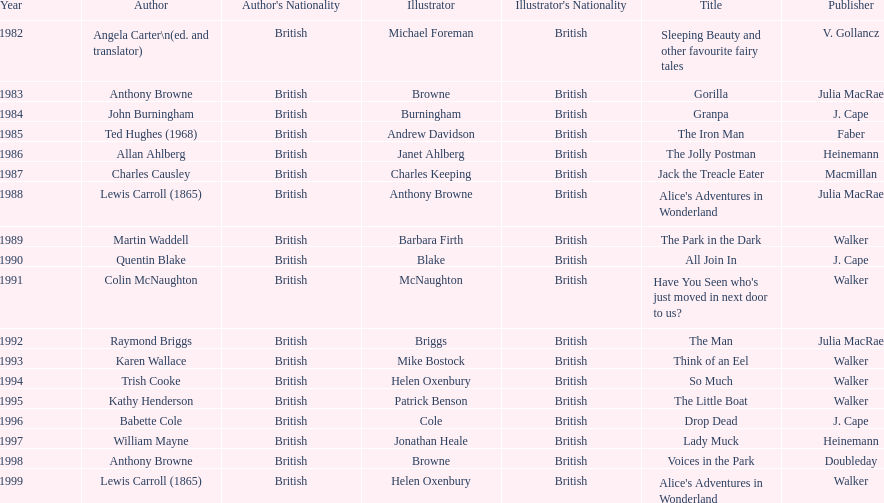Which author wrote the first award winner? Angela Carter. 